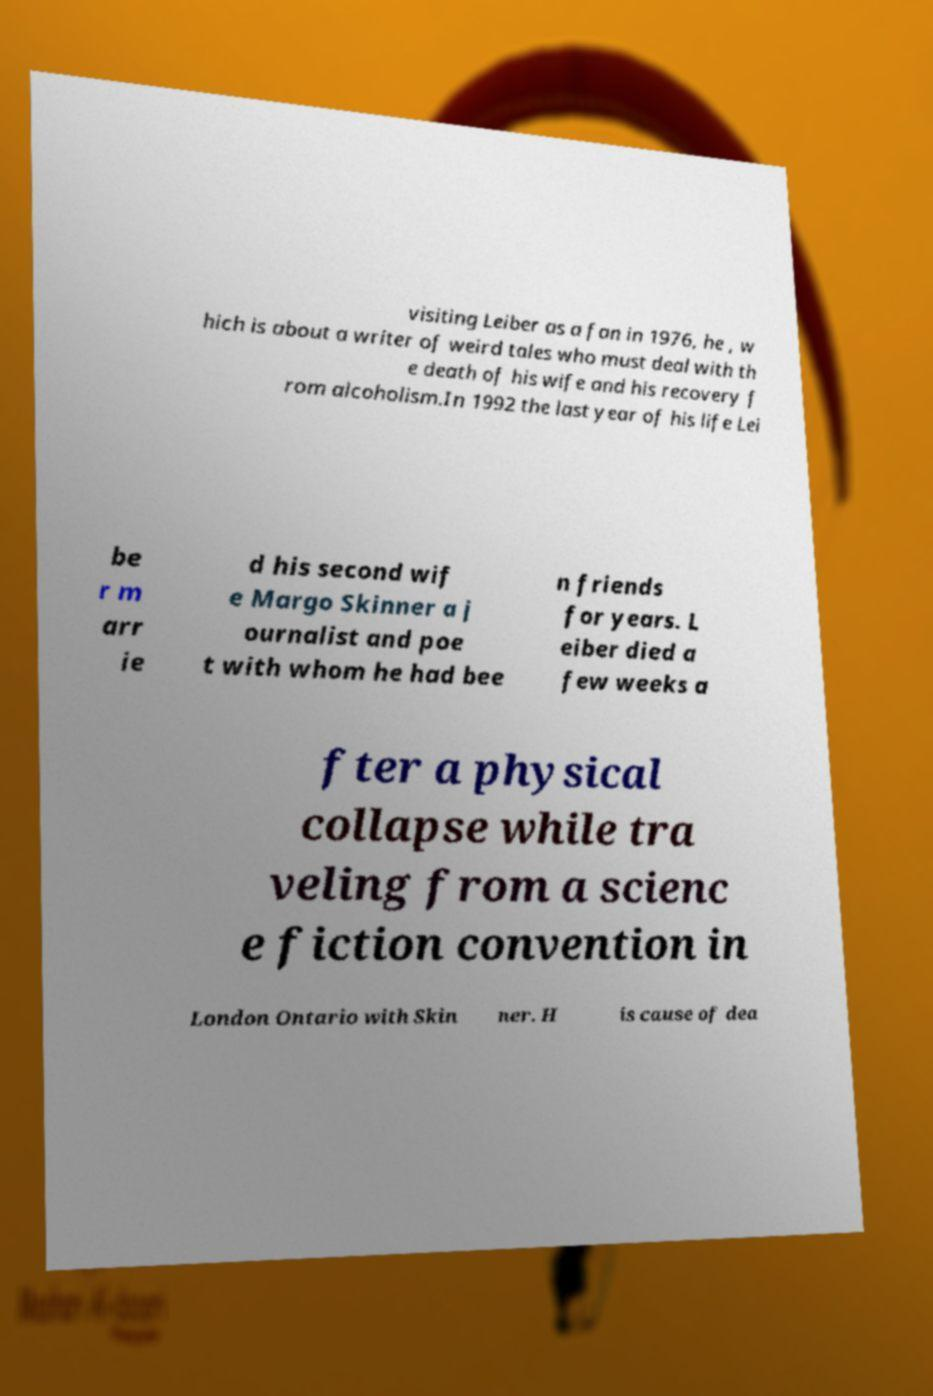For documentation purposes, I need the text within this image transcribed. Could you provide that? visiting Leiber as a fan in 1976, he , w hich is about a writer of weird tales who must deal with th e death of his wife and his recovery f rom alcoholism.In 1992 the last year of his life Lei be r m arr ie d his second wif e Margo Skinner a j ournalist and poe t with whom he had bee n friends for years. L eiber died a few weeks a fter a physical collapse while tra veling from a scienc e fiction convention in London Ontario with Skin ner. H is cause of dea 